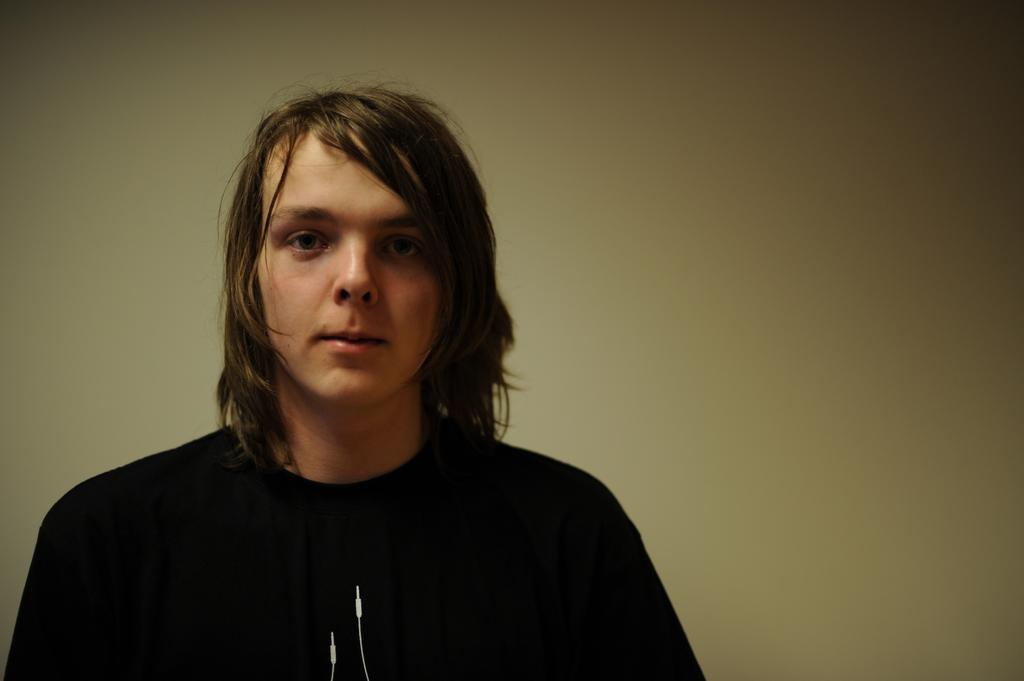What is: Who is present in the image? There is a boy standing in the image. What can be seen in the background of the image? There is a wall in the background of the image. How many cattle are visible in the image? There are no cattle present in the image. What type of trail can be seen in the image? There is no trail visible in the image. 